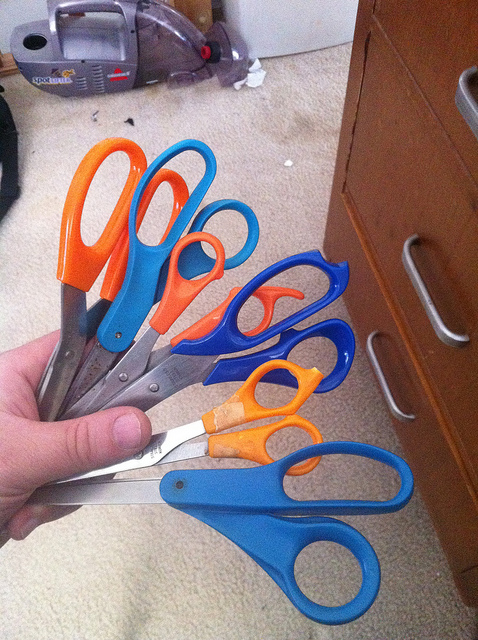Which pair of scissors appears to be the most used based on their condition? The second smallest pair of scissors, with orange and blue handles, shows signs of wear and some discoloration, suggesting it's been used more frequently than the others. 